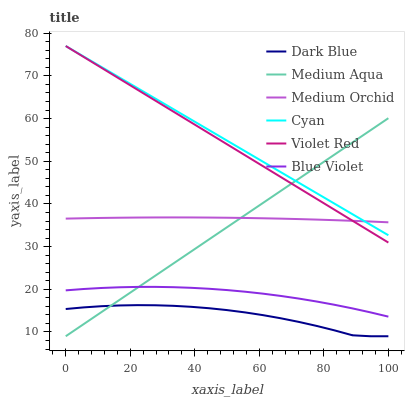Does Dark Blue have the minimum area under the curve?
Answer yes or no. Yes. Does Cyan have the maximum area under the curve?
Answer yes or no. Yes. Does Medium Orchid have the minimum area under the curve?
Answer yes or no. No. Does Medium Orchid have the maximum area under the curve?
Answer yes or no. No. Is Cyan the smoothest?
Answer yes or no. Yes. Is Dark Blue the roughest?
Answer yes or no. Yes. Is Medium Orchid the smoothest?
Answer yes or no. No. Is Medium Orchid the roughest?
Answer yes or no. No. Does Dark Blue have the lowest value?
Answer yes or no. Yes. Does Medium Orchid have the lowest value?
Answer yes or no. No. Does Cyan have the highest value?
Answer yes or no. Yes. Does Medium Orchid have the highest value?
Answer yes or no. No. Is Dark Blue less than Cyan?
Answer yes or no. Yes. Is Cyan greater than Blue Violet?
Answer yes or no. Yes. Does Cyan intersect Medium Orchid?
Answer yes or no. Yes. Is Cyan less than Medium Orchid?
Answer yes or no. No. Is Cyan greater than Medium Orchid?
Answer yes or no. No. Does Dark Blue intersect Cyan?
Answer yes or no. No. 